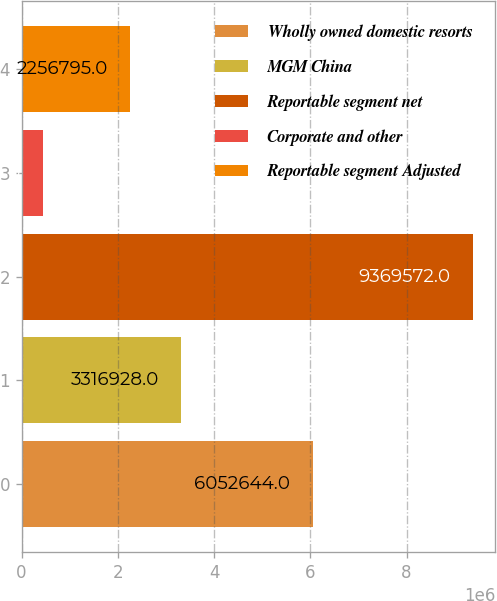Convert chart to OTSL. <chart><loc_0><loc_0><loc_500><loc_500><bar_chart><fcel>Wholly owned domestic resorts<fcel>MGM China<fcel>Reportable segment net<fcel>Corporate and other<fcel>Reportable segment Adjusted<nl><fcel>6.05264e+06<fcel>3.31693e+06<fcel>9.36957e+06<fcel>440091<fcel>2.2568e+06<nl></chart> 